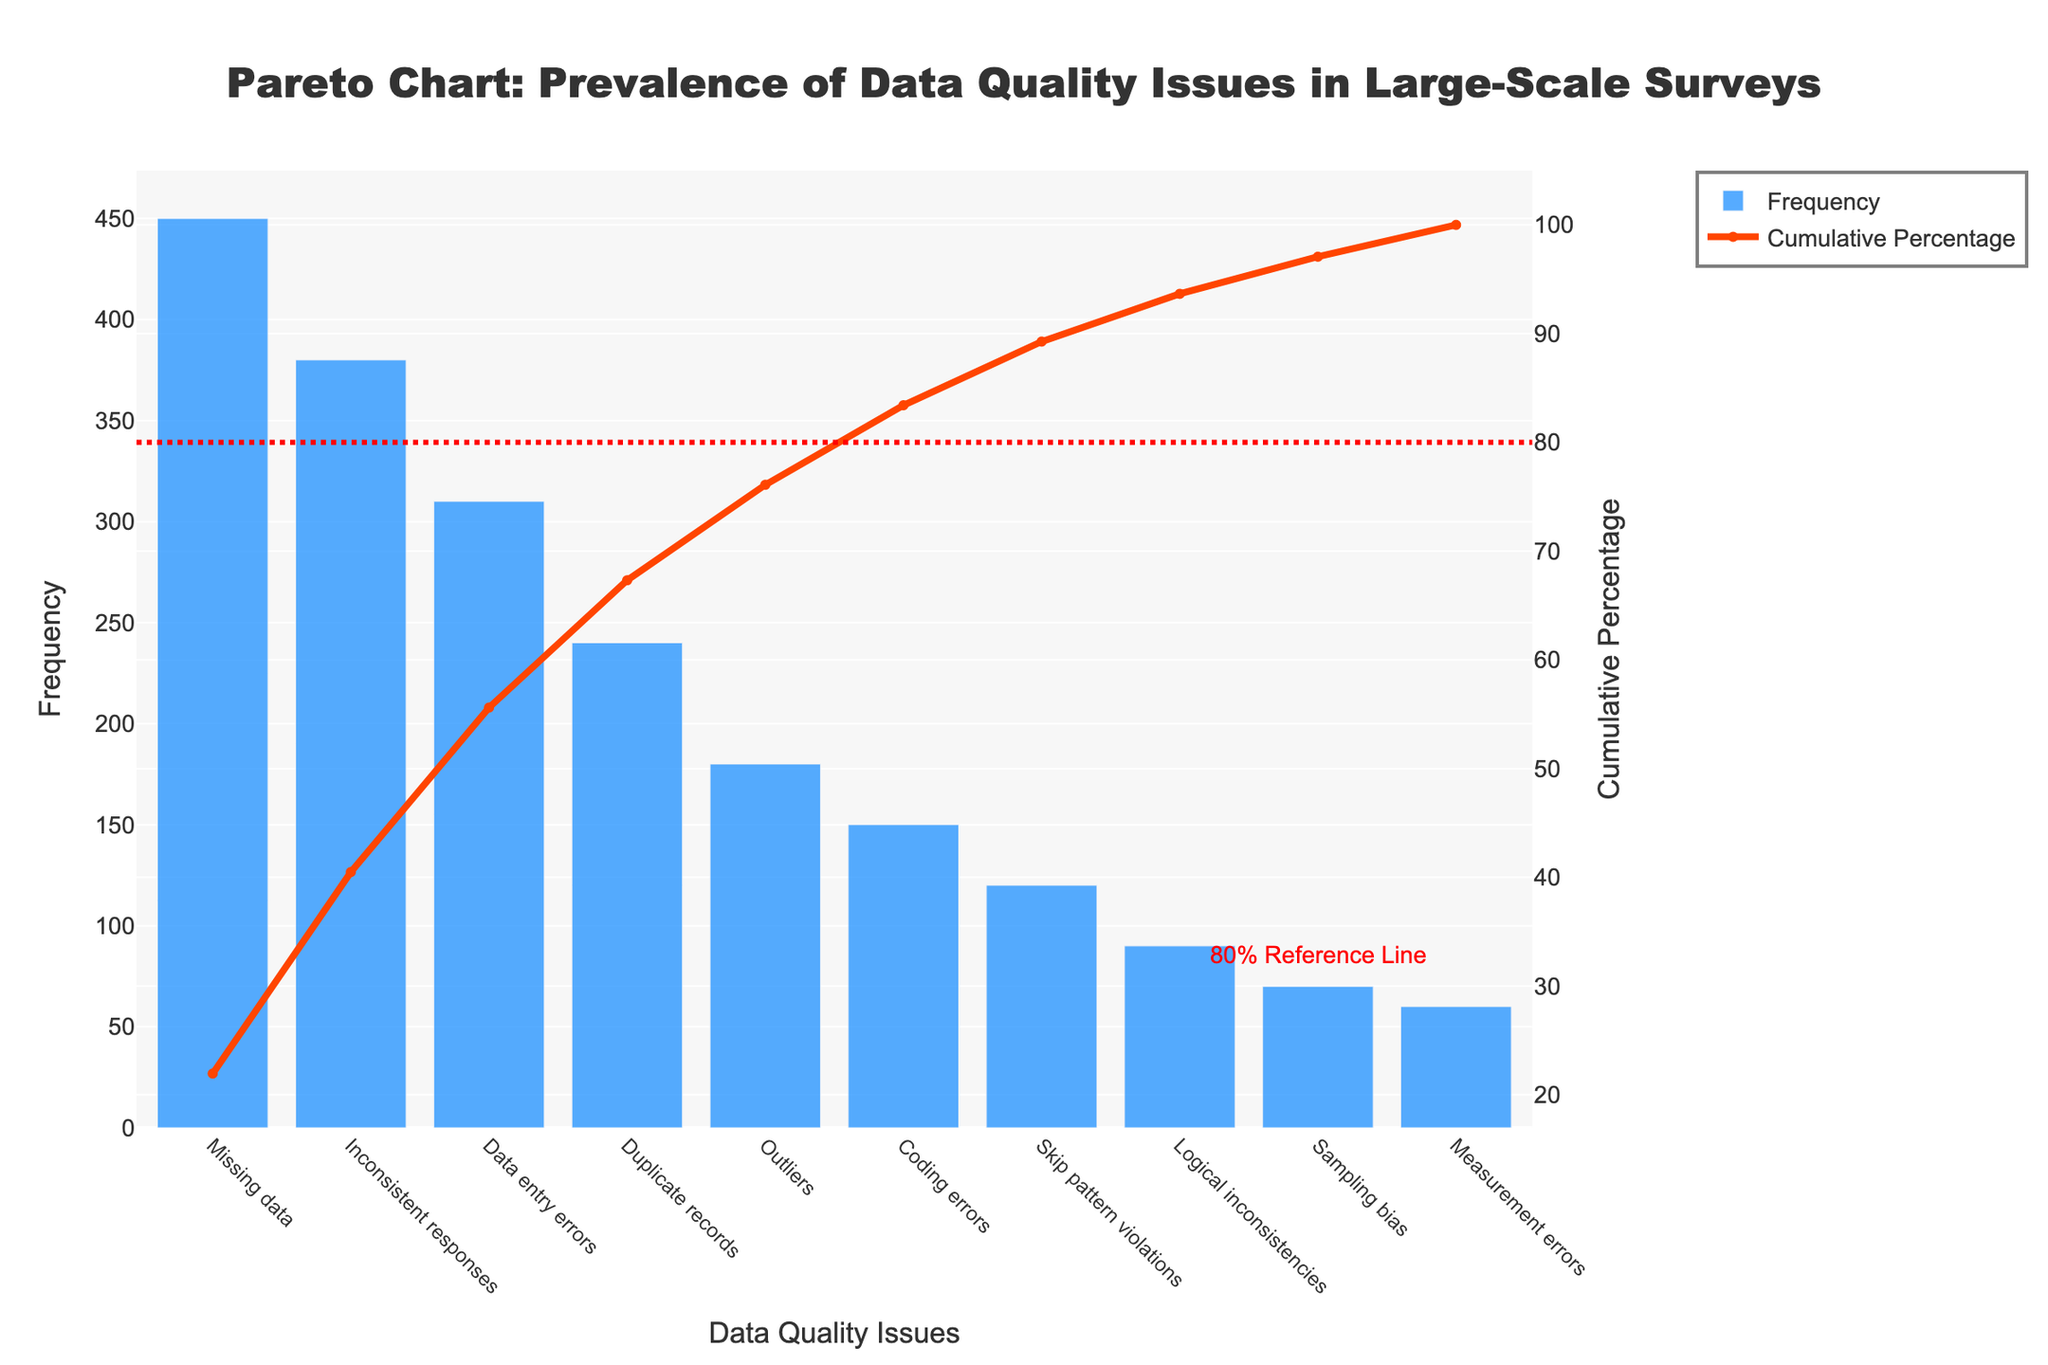What is the most common data quality issue in the survey? According to the Pareto chart, the most common data quality issue has the highest bar, which is "Missing data" with a frequency of 450.
Answer: Missing data Which data quality issue has the lowest frequency? The issue with the lowest frequency is the one represented by the shortest bar in the chart, which is "Measurement errors" with a frequency of 60.
Answer: Measurement errors What percentage of the total issues do the top three issues represent? The cumulative percentage for the top three issues ("Missing data", "Inconsistent responses", and "Data entry errors") can be found by summing their individual cumulative percentages. The chart indicates the cumulative percentage at the third bar (Data entry errors) is 70%.
Answer: 70% How does the frequency of "Duplicate records" compare to "Outliers"? By looking at the heights of their respective bars, "Duplicate records" have a frequency of 240, while "Outliers" have a frequency of 180. So, "Duplicate records" are more frequent.
Answer: "Duplicate records" are more frequent At which point does the cumulative percentage exceed 80%? The cumulative percentage curve and the 80% reference line on the chart indicate that the cumulative percentage exceeds 80% right after the bar for "Skip pattern violations".
Answer: At "Skip pattern violations" How many data quality issues have a frequency greater than 200? We count the number of bars with a height exceeding 200. These are "Missing data", "Inconsistent responses", "Data entry errors", and "Duplicate records". That totals to four issues.
Answer: Four What is the cumulative percentage of all issues after including "Logical inconsistencies"? The cumulative percentage line at the "Logical inconsistencies" bar is observed on the secondary y-axis, which is around 93%.
Answer: 93% Which data quality issues together account for roughly half of the total frequency? By analyzing the cumulative percentage line, the first three data quality issues ("Missing data", "Inconsistent responses", and "Data entry errors") account for around 70%, which is more than half. Going one step back, the first two issues ("Missing data" and "Inconsistent responses") sum to about 55% of the cumulative percentage. So these two issues account for roughly half of the total frequency.
Answer: "Missing data" and "Inconsistent responses" 